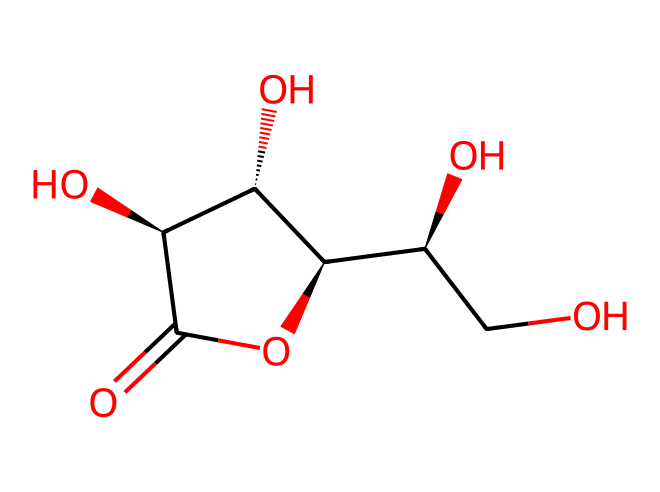What is the name of this vitamin? The SMILES representation corresponds to the molecular structure of ascorbic acid, commonly known as Vitamin C. By identifying the functional groups and structure within the SMILES, it is clear that this is Vitamin C.
Answer: Vitamin C How many carbon atoms are in this structure? By analyzing the SMILES representation, we can count the carbon atoms depicted. The carbon atoms are denoted in the structure, totaling six in this case.
Answer: six What type of functional groups are present in this chemical? The structure includes hydroxyl (-OH) groups, which are typical of alcohols, and a carbonyl (C=O) group. This indicates the presence of multiple functional groups, specifically hydroxyl groups.
Answer: hydroxyl How many chiral centers are in this molecule? A careful examination of the carbon centers where the substituents differ indicates the presence of four chiral centers. Chiral centers are typically found at carbon atoms bonded to four different groups.
Answer: four Is this vitamin water-soluble? Given that Vitamin C, or ascorbic acid, has multiple hydroxyl groups, it exhibits high polarity and is soluble in water. The presence of these functional groups shows its affinity for water.
Answer: yes What structural feature gives Vitamin C its acidic properties? The presence of the carbonyl group (C=O) and the hydroxyl groups (-OH) contributes to the acidic nature of ascorbic acid by allowing for proton donation (H+). This structural characteristic enables its acidic behavior.
Answer: carbonyl group 